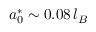<formula> <loc_0><loc_0><loc_500><loc_500>a _ { 0 } ^ { * } \sim 0 . 0 8 \, l _ { B }</formula> 